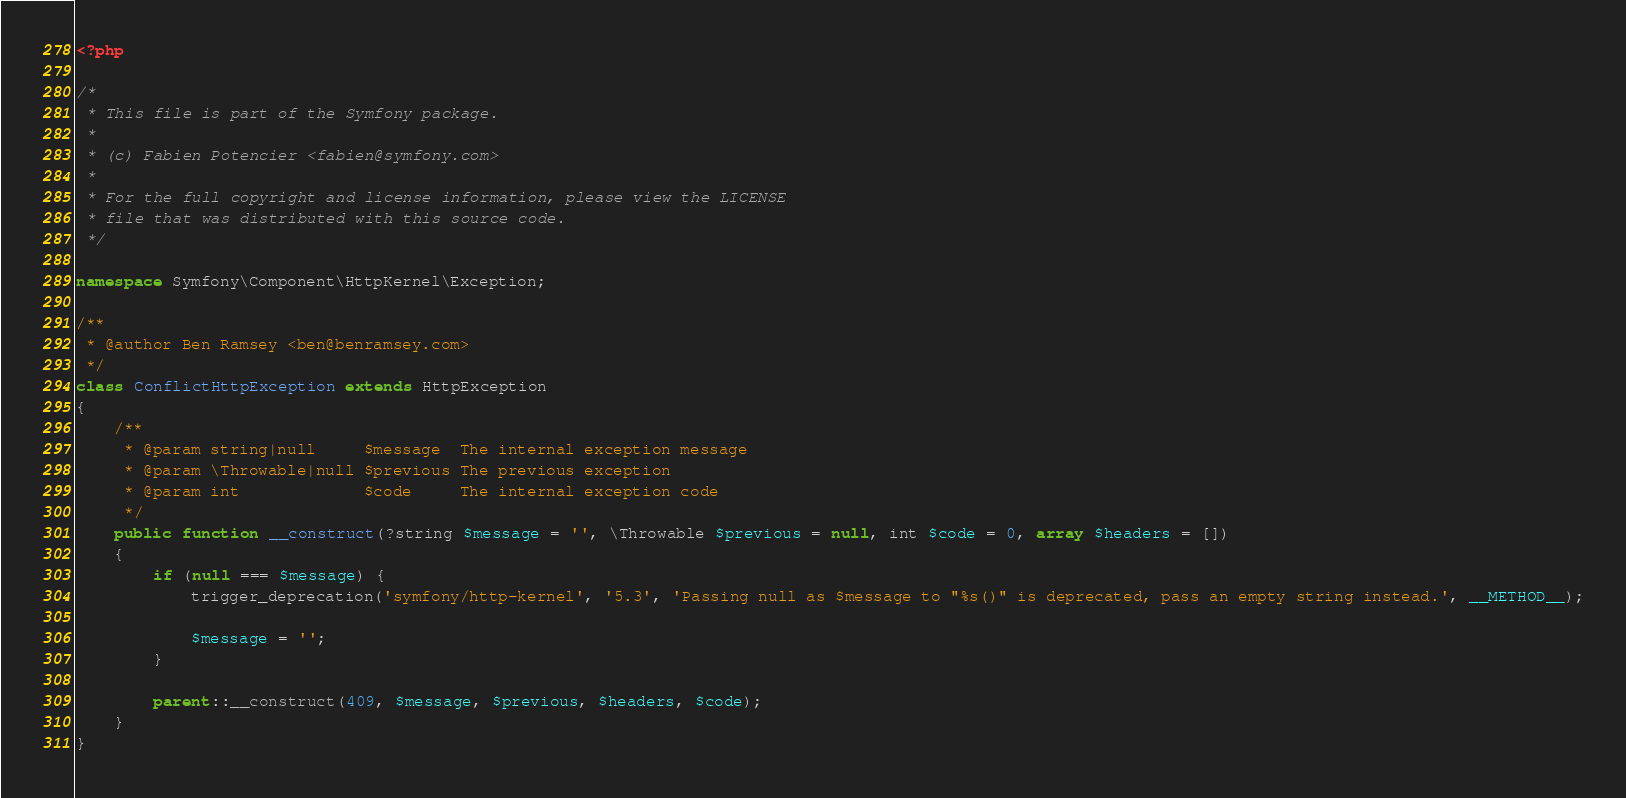<code> <loc_0><loc_0><loc_500><loc_500><_PHP_><?php

/*
 * This file is part of the Symfony package.
 *
 * (c) Fabien Potencier <fabien@symfony.com>
 *
 * For the full copyright and license information, please view the LICENSE
 * file that was distributed with this source code.
 */

namespace Symfony\Component\HttpKernel\Exception;

/**
 * @author Ben Ramsey <ben@benramsey.com>
 */
class ConflictHttpException extends HttpException
{
    /**
     * @param string|null     $message  The internal exception message
     * @param \Throwable|null $previous The previous exception
     * @param int             $code     The internal exception code
     */
    public function __construct(?string $message = '', \Throwable $previous = null, int $code = 0, array $headers = [])
    {
        if (null === $message) {
            trigger_deprecation('symfony/http-kernel', '5.3', 'Passing null as $message to "%s()" is deprecated, pass an empty string instead.', __METHOD__);

            $message = '';
        }

        parent::__construct(409, $message, $previous, $headers, $code);
    }
}
</code> 